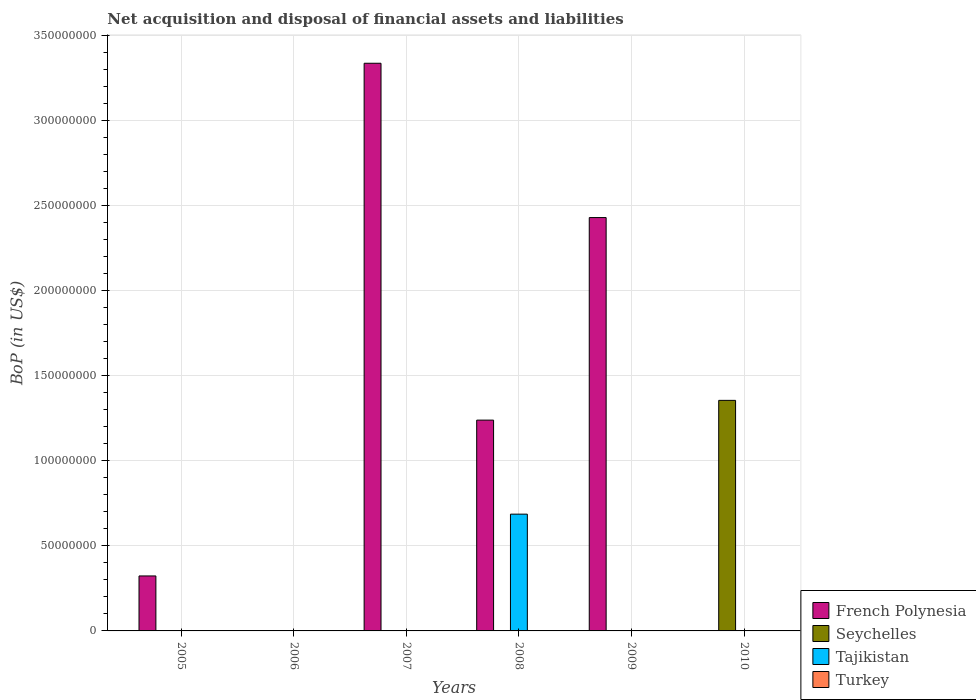Are the number of bars per tick equal to the number of legend labels?
Offer a terse response. No. What is the label of the 4th group of bars from the left?
Provide a succinct answer. 2008. In how many cases, is the number of bars for a given year not equal to the number of legend labels?
Ensure brevity in your answer.  6. What is the Balance of Payments in Turkey in 2008?
Make the answer very short. 0. Across all years, what is the maximum Balance of Payments in Seychelles?
Offer a terse response. 1.36e+08. In which year was the Balance of Payments in Tajikistan maximum?
Your answer should be compact. 2008. What is the total Balance of Payments in Tajikistan in the graph?
Your answer should be compact. 6.87e+07. What is the difference between the Balance of Payments in French Polynesia in 2007 and that in 2009?
Offer a very short reply. 9.07e+07. What is the difference between the Balance of Payments in Turkey in 2007 and the Balance of Payments in Tajikistan in 2006?
Offer a very short reply. 0. What is the average Balance of Payments in Turkey per year?
Offer a very short reply. 0. Is the Balance of Payments in French Polynesia in 2008 less than that in 2009?
Give a very brief answer. Yes. What is the difference between the highest and the second highest Balance of Payments in French Polynesia?
Keep it short and to the point. 9.07e+07. What is the difference between the highest and the lowest Balance of Payments in Seychelles?
Give a very brief answer. 1.36e+08. Is it the case that in every year, the sum of the Balance of Payments in French Polynesia and Balance of Payments in Seychelles is greater than the Balance of Payments in Turkey?
Offer a terse response. No. How many bars are there?
Make the answer very short. 6. How many years are there in the graph?
Your response must be concise. 6. Are the values on the major ticks of Y-axis written in scientific E-notation?
Keep it short and to the point. No. Where does the legend appear in the graph?
Your response must be concise. Bottom right. How many legend labels are there?
Your answer should be very brief. 4. What is the title of the graph?
Ensure brevity in your answer.  Net acquisition and disposal of financial assets and liabilities. Does "Serbia" appear as one of the legend labels in the graph?
Ensure brevity in your answer.  No. What is the label or title of the X-axis?
Offer a terse response. Years. What is the label or title of the Y-axis?
Provide a short and direct response. BoP (in US$). What is the BoP (in US$) of French Polynesia in 2005?
Your answer should be very brief. 3.23e+07. What is the BoP (in US$) of Turkey in 2005?
Your answer should be compact. 0. What is the BoP (in US$) in French Polynesia in 2006?
Your answer should be very brief. 0. What is the BoP (in US$) in French Polynesia in 2007?
Provide a short and direct response. 3.34e+08. What is the BoP (in US$) of Seychelles in 2007?
Your answer should be compact. 0. What is the BoP (in US$) of French Polynesia in 2008?
Offer a terse response. 1.24e+08. What is the BoP (in US$) in Seychelles in 2008?
Offer a very short reply. 0. What is the BoP (in US$) of Tajikistan in 2008?
Provide a succinct answer. 6.87e+07. What is the BoP (in US$) of Turkey in 2008?
Offer a very short reply. 0. What is the BoP (in US$) in French Polynesia in 2009?
Your response must be concise. 2.43e+08. What is the BoP (in US$) in Seychelles in 2009?
Give a very brief answer. 0. What is the BoP (in US$) of Tajikistan in 2009?
Keep it short and to the point. 0. What is the BoP (in US$) of French Polynesia in 2010?
Provide a succinct answer. 0. What is the BoP (in US$) in Seychelles in 2010?
Make the answer very short. 1.36e+08. What is the BoP (in US$) of Turkey in 2010?
Provide a short and direct response. 0. Across all years, what is the maximum BoP (in US$) in French Polynesia?
Ensure brevity in your answer.  3.34e+08. Across all years, what is the maximum BoP (in US$) of Seychelles?
Your answer should be compact. 1.36e+08. Across all years, what is the maximum BoP (in US$) in Tajikistan?
Provide a succinct answer. 6.87e+07. What is the total BoP (in US$) in French Polynesia in the graph?
Keep it short and to the point. 7.33e+08. What is the total BoP (in US$) of Seychelles in the graph?
Ensure brevity in your answer.  1.36e+08. What is the total BoP (in US$) in Tajikistan in the graph?
Keep it short and to the point. 6.87e+07. What is the difference between the BoP (in US$) in French Polynesia in 2005 and that in 2007?
Offer a very short reply. -3.01e+08. What is the difference between the BoP (in US$) in French Polynesia in 2005 and that in 2008?
Offer a terse response. -9.16e+07. What is the difference between the BoP (in US$) in French Polynesia in 2005 and that in 2009?
Offer a terse response. -2.11e+08. What is the difference between the BoP (in US$) in French Polynesia in 2007 and that in 2008?
Your answer should be very brief. 2.10e+08. What is the difference between the BoP (in US$) in French Polynesia in 2007 and that in 2009?
Keep it short and to the point. 9.07e+07. What is the difference between the BoP (in US$) in French Polynesia in 2008 and that in 2009?
Offer a terse response. -1.19e+08. What is the difference between the BoP (in US$) of French Polynesia in 2005 and the BoP (in US$) of Tajikistan in 2008?
Keep it short and to the point. -3.63e+07. What is the difference between the BoP (in US$) of French Polynesia in 2005 and the BoP (in US$) of Seychelles in 2010?
Your answer should be compact. -1.03e+08. What is the difference between the BoP (in US$) in French Polynesia in 2007 and the BoP (in US$) in Tajikistan in 2008?
Make the answer very short. 2.65e+08. What is the difference between the BoP (in US$) of French Polynesia in 2007 and the BoP (in US$) of Seychelles in 2010?
Keep it short and to the point. 1.98e+08. What is the difference between the BoP (in US$) in French Polynesia in 2008 and the BoP (in US$) in Seychelles in 2010?
Keep it short and to the point. -1.16e+07. What is the difference between the BoP (in US$) in French Polynesia in 2009 and the BoP (in US$) in Seychelles in 2010?
Your response must be concise. 1.07e+08. What is the average BoP (in US$) in French Polynesia per year?
Make the answer very short. 1.22e+08. What is the average BoP (in US$) of Seychelles per year?
Offer a very short reply. 2.26e+07. What is the average BoP (in US$) in Tajikistan per year?
Your answer should be very brief. 1.14e+07. In the year 2008, what is the difference between the BoP (in US$) in French Polynesia and BoP (in US$) in Tajikistan?
Ensure brevity in your answer.  5.53e+07. What is the ratio of the BoP (in US$) in French Polynesia in 2005 to that in 2007?
Provide a succinct answer. 0.1. What is the ratio of the BoP (in US$) in French Polynesia in 2005 to that in 2008?
Provide a succinct answer. 0.26. What is the ratio of the BoP (in US$) of French Polynesia in 2005 to that in 2009?
Provide a short and direct response. 0.13. What is the ratio of the BoP (in US$) in French Polynesia in 2007 to that in 2008?
Ensure brevity in your answer.  2.69. What is the ratio of the BoP (in US$) in French Polynesia in 2007 to that in 2009?
Your response must be concise. 1.37. What is the ratio of the BoP (in US$) of French Polynesia in 2008 to that in 2009?
Your answer should be very brief. 0.51. What is the difference between the highest and the second highest BoP (in US$) in French Polynesia?
Give a very brief answer. 9.07e+07. What is the difference between the highest and the lowest BoP (in US$) in French Polynesia?
Provide a short and direct response. 3.34e+08. What is the difference between the highest and the lowest BoP (in US$) in Seychelles?
Offer a terse response. 1.36e+08. What is the difference between the highest and the lowest BoP (in US$) of Tajikistan?
Provide a succinct answer. 6.87e+07. 